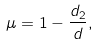Convert formula to latex. <formula><loc_0><loc_0><loc_500><loc_500>\mu = 1 - \frac { d _ { 2 } } { d } ,</formula> 